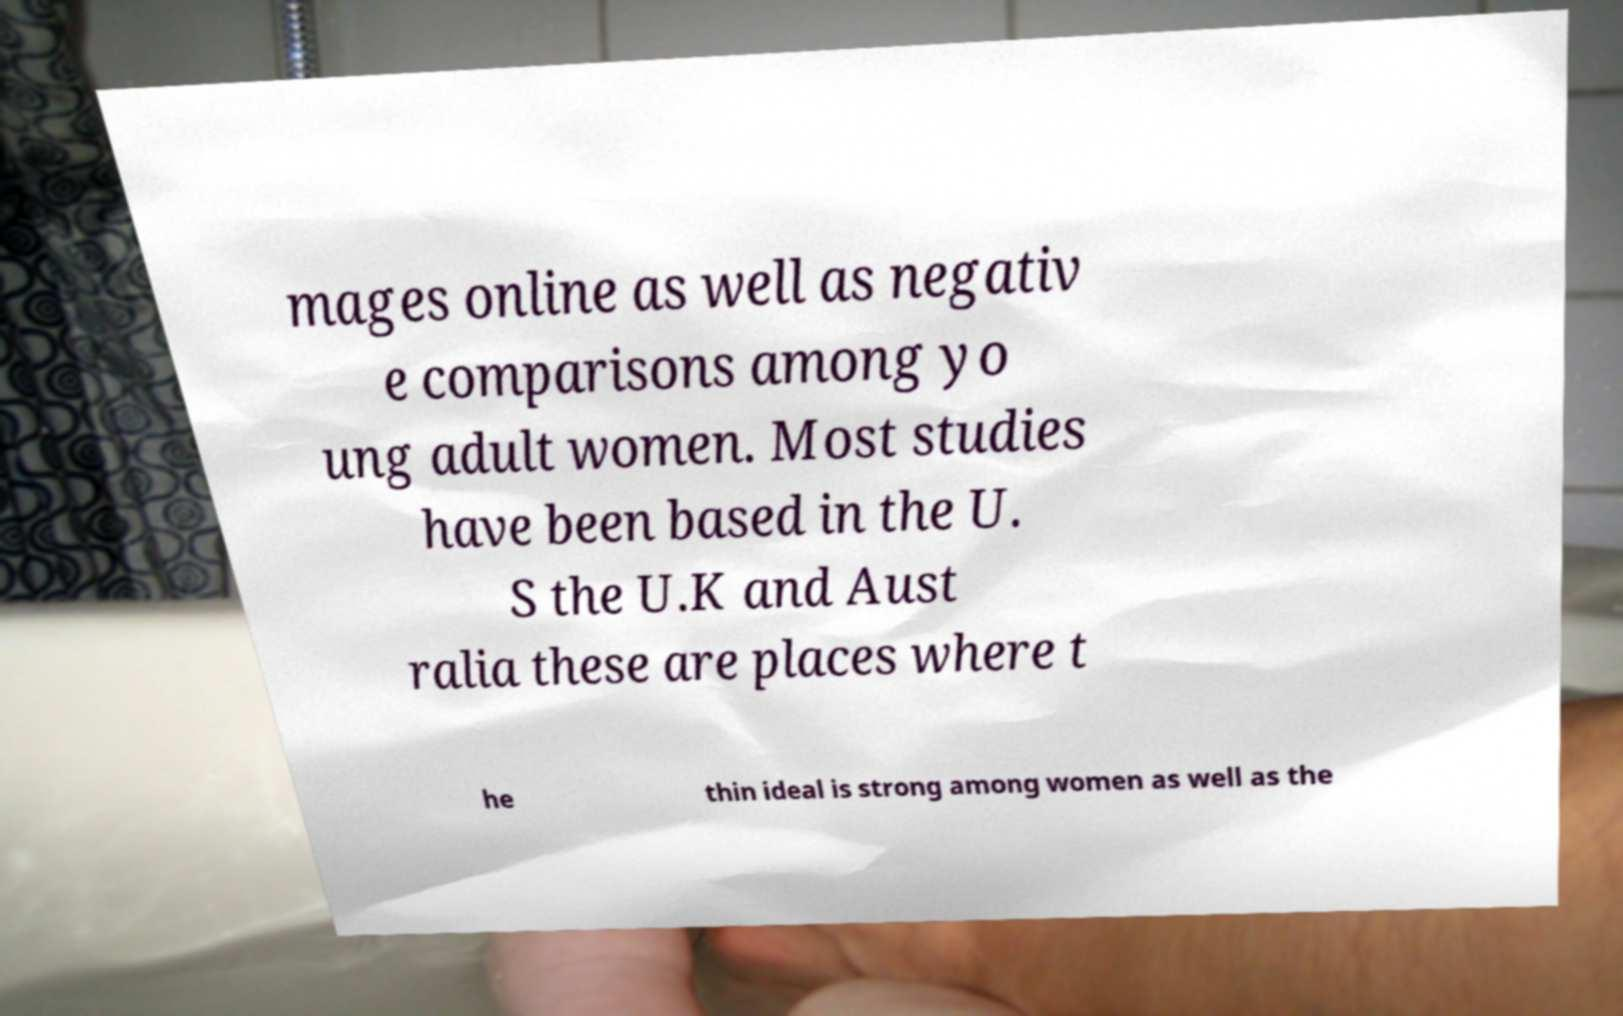What messages or text are displayed in this image? I need them in a readable, typed format. mages online as well as negativ e comparisons among yo ung adult women. Most studies have been based in the U. S the U.K and Aust ralia these are places where t he thin ideal is strong among women as well as the 